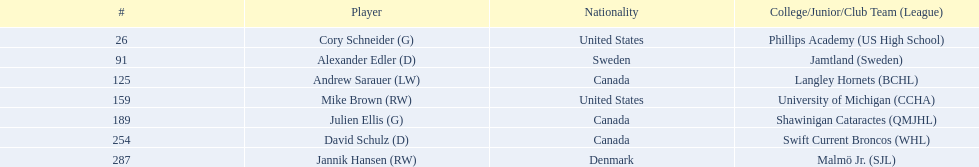Which player was the first player to be drafted? Cory Schneider (G). Parse the full table. {'header': ['#', 'Player', 'Nationality', 'College/Junior/Club Team (League)'], 'rows': [['26', 'Cory Schneider (G)', 'United States', 'Phillips Academy (US High School)'], ['91', 'Alexander Edler (D)', 'Sweden', 'Jamtland (Sweden)'], ['125', 'Andrew Sarauer (LW)', 'Canada', 'Langley Hornets (BCHL)'], ['159', 'Mike Brown (RW)', 'United States', 'University of Michigan (CCHA)'], ['189', 'Julien Ellis (G)', 'Canada', 'Shawinigan Cataractes (QMJHL)'], ['254', 'David Schulz (D)', 'Canada', 'Swift Current Broncos (WHL)'], ['287', 'Jannik Hansen (RW)', 'Denmark', 'Malmö Jr. (SJL)']]} 